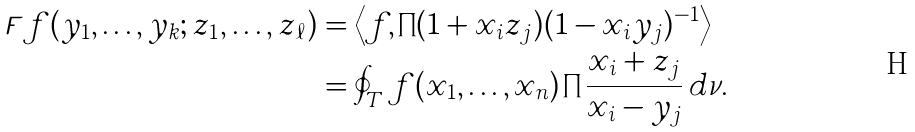<formula> <loc_0><loc_0><loc_500><loc_500>\digamma f ( y _ { 1 } , \dots , y _ { k } ; z _ { 1 } , \dots , z _ { \ell } ) & = \left \langle f , \prod ( 1 + x _ { i } z _ { j } ) ( 1 - x _ { i } y _ { j } ) ^ { - 1 } \right \rangle \\ & = \oint _ { T } f ( x _ { 1 } , \dots , x _ { n } ) \prod \frac { x _ { i } + z _ { j } } { x _ { i } - y _ { j } } \, d \nu .</formula> 